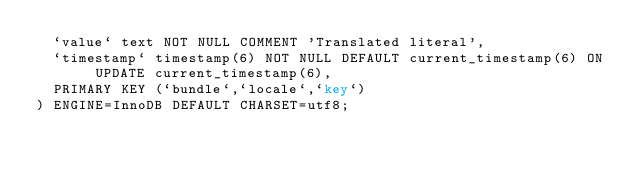Convert code to text. <code><loc_0><loc_0><loc_500><loc_500><_SQL_>  `value` text NOT NULL COMMENT 'Translated literal',
  `timestamp` timestamp(6) NOT NULL DEFAULT current_timestamp(6) ON UPDATE current_timestamp(6),
  PRIMARY KEY (`bundle`,`locale`,`key`)
) ENGINE=InnoDB DEFAULT CHARSET=utf8;
</code> 